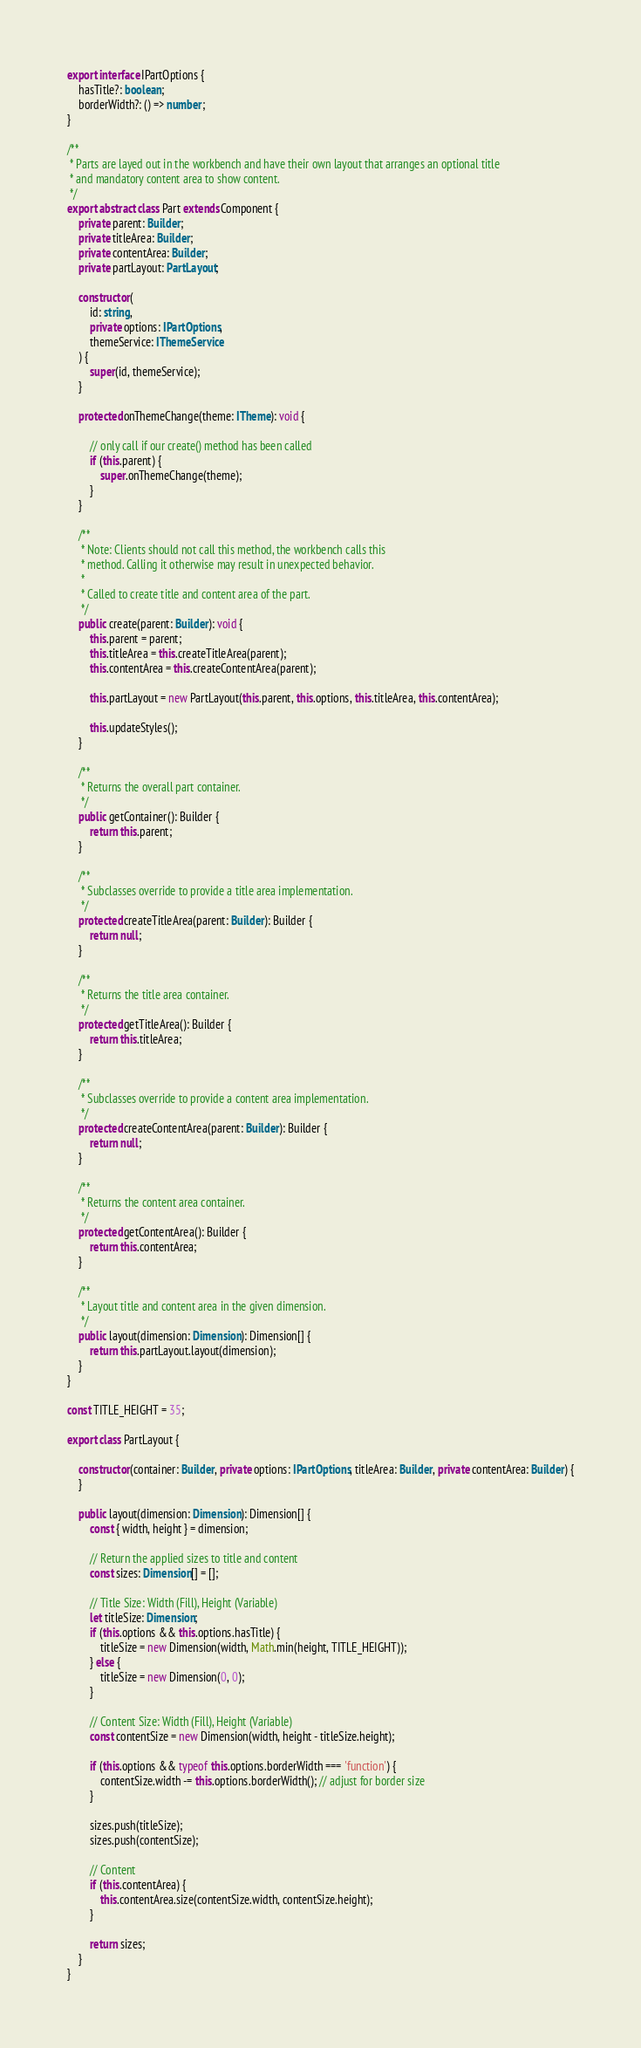Convert code to text. <code><loc_0><loc_0><loc_500><loc_500><_TypeScript_>export interface IPartOptions {
	hasTitle?: boolean;
	borderWidth?: () => number;
}

/**
 * Parts are layed out in the workbench and have their own layout that arranges an optional title
 * and mandatory content area to show content.
 */
export abstract class Part extends Component {
	private parent: Builder;
	private titleArea: Builder;
	private contentArea: Builder;
	private partLayout: PartLayout;

	constructor(
		id: string,
		private options: IPartOptions,
		themeService: IThemeService
	) {
		super(id, themeService);
	}

	protected onThemeChange(theme: ITheme): void {

		// only call if our create() method has been called
		if (this.parent) {
			super.onThemeChange(theme);
		}
	}

	/**
	 * Note: Clients should not call this method, the workbench calls this
	 * method. Calling it otherwise may result in unexpected behavior.
	 *
	 * Called to create title and content area of the part.
	 */
	public create(parent: Builder): void {
		this.parent = parent;
		this.titleArea = this.createTitleArea(parent);
		this.contentArea = this.createContentArea(parent);

		this.partLayout = new PartLayout(this.parent, this.options, this.titleArea, this.contentArea);

		this.updateStyles();
	}

	/**
	 * Returns the overall part container.
	 */
	public getContainer(): Builder {
		return this.parent;
	}

	/**
	 * Subclasses override to provide a title area implementation.
	 */
	protected createTitleArea(parent: Builder): Builder {
		return null;
	}

	/**
	 * Returns the title area container.
	 */
	protected getTitleArea(): Builder {
		return this.titleArea;
	}

	/**
	 * Subclasses override to provide a content area implementation.
	 */
	protected createContentArea(parent: Builder): Builder {
		return null;
	}

	/**
	 * Returns the content area container.
	 */
	protected getContentArea(): Builder {
		return this.contentArea;
	}

	/**
	 * Layout title and content area in the given dimension.
	 */
	public layout(dimension: Dimension): Dimension[] {
		return this.partLayout.layout(dimension);
	}
}

const TITLE_HEIGHT = 35;

export class PartLayout {

	constructor(container: Builder, private options: IPartOptions, titleArea: Builder, private contentArea: Builder) {
	}

	public layout(dimension: Dimension): Dimension[] {
		const { width, height } = dimension;

		// Return the applied sizes to title and content
		const sizes: Dimension[] = [];

		// Title Size: Width (Fill), Height (Variable)
		let titleSize: Dimension;
		if (this.options && this.options.hasTitle) {
			titleSize = new Dimension(width, Math.min(height, TITLE_HEIGHT));
		} else {
			titleSize = new Dimension(0, 0);
		}

		// Content Size: Width (Fill), Height (Variable)
		const contentSize = new Dimension(width, height - titleSize.height);

		if (this.options && typeof this.options.borderWidth === 'function') {
			contentSize.width -= this.options.borderWidth(); // adjust for border size
		}

		sizes.push(titleSize);
		sizes.push(contentSize);

		// Content
		if (this.contentArea) {
			this.contentArea.size(contentSize.width, contentSize.height);
		}

		return sizes;
	}
}</code> 